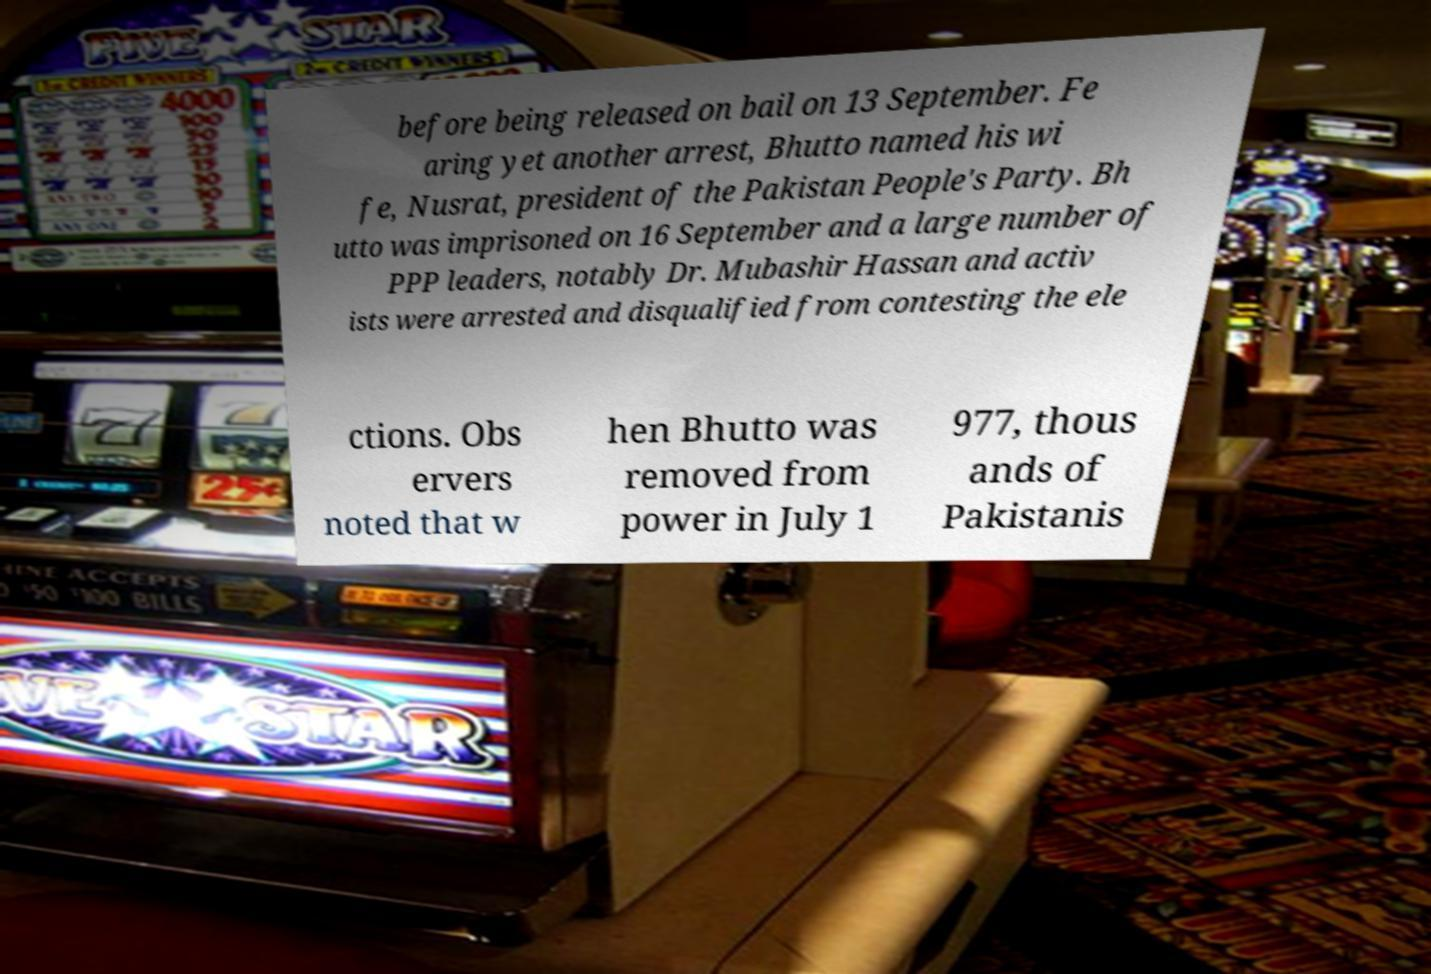Could you extract and type out the text from this image? before being released on bail on 13 September. Fe aring yet another arrest, Bhutto named his wi fe, Nusrat, president of the Pakistan People's Party. Bh utto was imprisoned on 16 September and a large number of PPP leaders, notably Dr. Mubashir Hassan and activ ists were arrested and disqualified from contesting the ele ctions. Obs ervers noted that w hen Bhutto was removed from power in July 1 977, thous ands of Pakistanis 